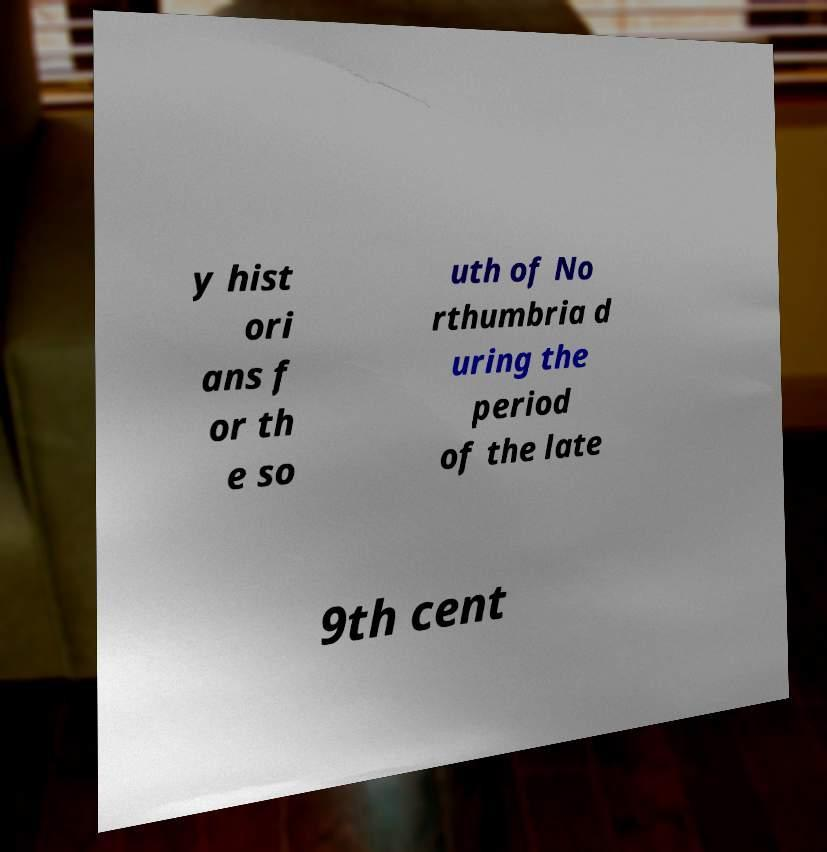There's text embedded in this image that I need extracted. Can you transcribe it verbatim? y hist ori ans f or th e so uth of No rthumbria d uring the period of the late 9th cent 